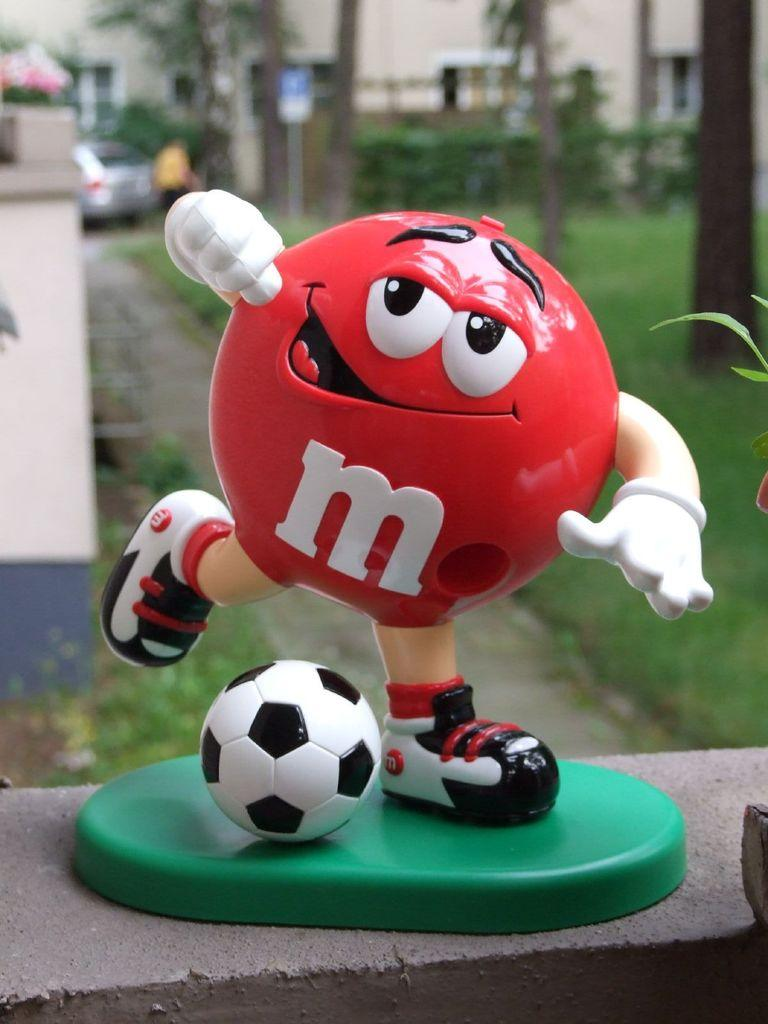What type of toy is present in the image? The toy is a ball with two hands and two legs. What is the toy's primary material? The toy is a ball, which is typically made of rubber or plastic. What type of natural environment can be seen in the image? There is grass, trees, and a path in the image, which suggests a park or outdoor setting. What type of structure is present in the image? There is a building in the image. How is the background of the image? The background of the image is blurred. What type of ice can be seen melting in the image? There is no ice present in the image. 